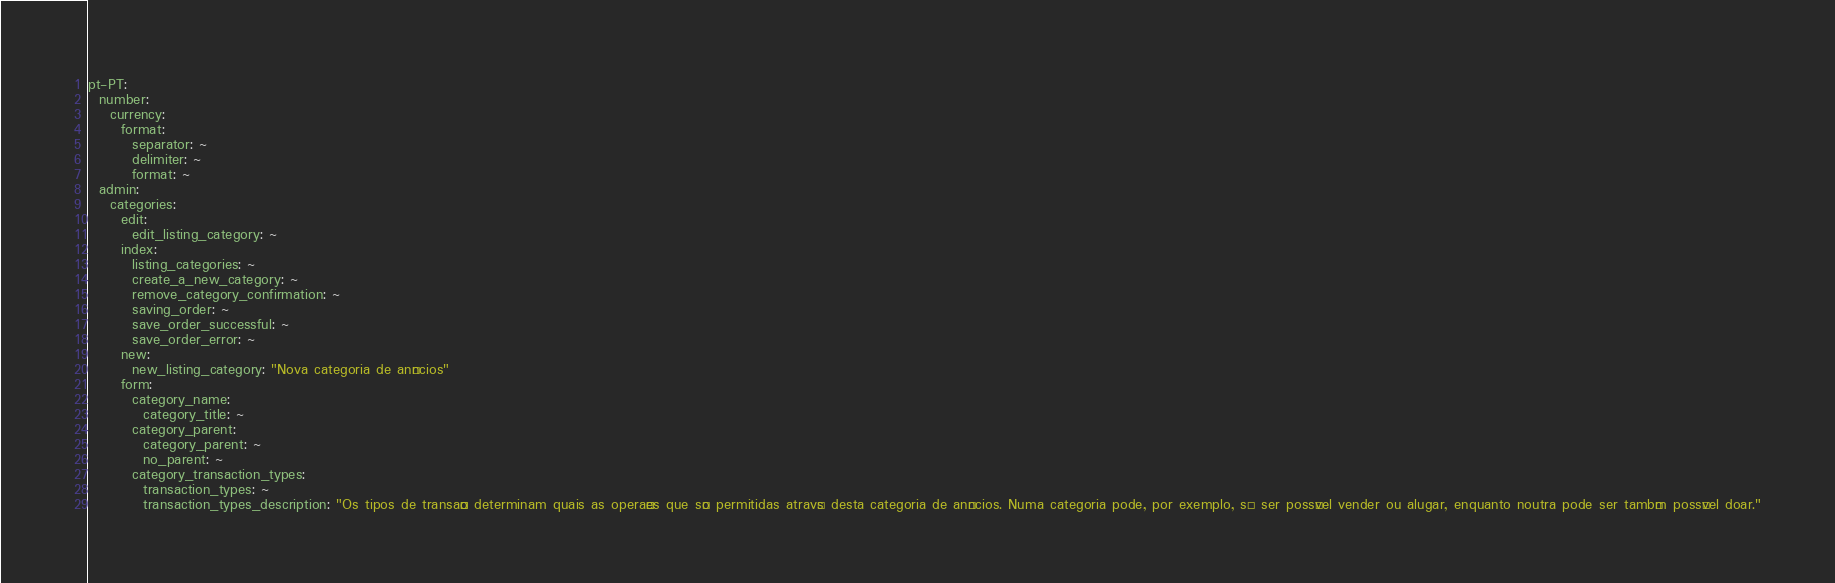<code> <loc_0><loc_0><loc_500><loc_500><_YAML_>pt-PT:
  number:
    currency:
      format:
        separator: ~
        delimiter: ~
        format: ~
  admin:
    categories:
      edit:
        edit_listing_category: ~
      index:
        listing_categories: ~
        create_a_new_category: ~
        remove_category_confirmation: ~
        saving_order: ~
        save_order_successful: ~
        save_order_error: ~
      new:
        new_listing_category: "Nova categoria de anúncios"
      form:
        category_name:
          category_title: ~
        category_parent:
          category_parent: ~
          no_parent: ~
        category_transaction_types:
          transaction_types: ~
          transaction_types_description: "Os tipos de transação determinam quais as operações que são permitidas através desta categoria de anúncios. Numa categoria pode, por exemplo, só ser possível vender ou alugar, enquanto noutra pode ser também possível doar."</code> 